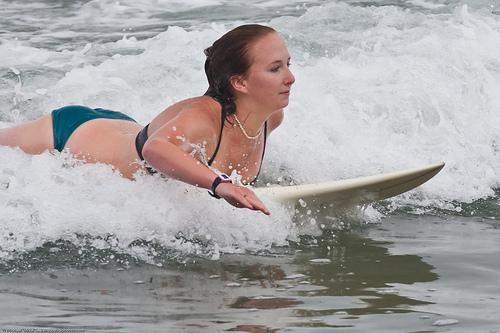Question: what is the woman doing?
Choices:
A. Skiing.
B. Jet skiing.
C. Surfing.
D. Boating.
Answer with the letter. Answer: C Question: what is the woman riding on?
Choices:
A. Surfboard.
B. Skis.
C. Wakeboard.
D. Skateboard.
Answer with the letter. Answer: A Question: why is the woman's arm raised?
Choices:
A. She is going to ask a question.
B. She is saluting.
C. She is paddling.
D. She is keeping it above her heart to stop bleeding.
Answer with the letter. Answer: C 